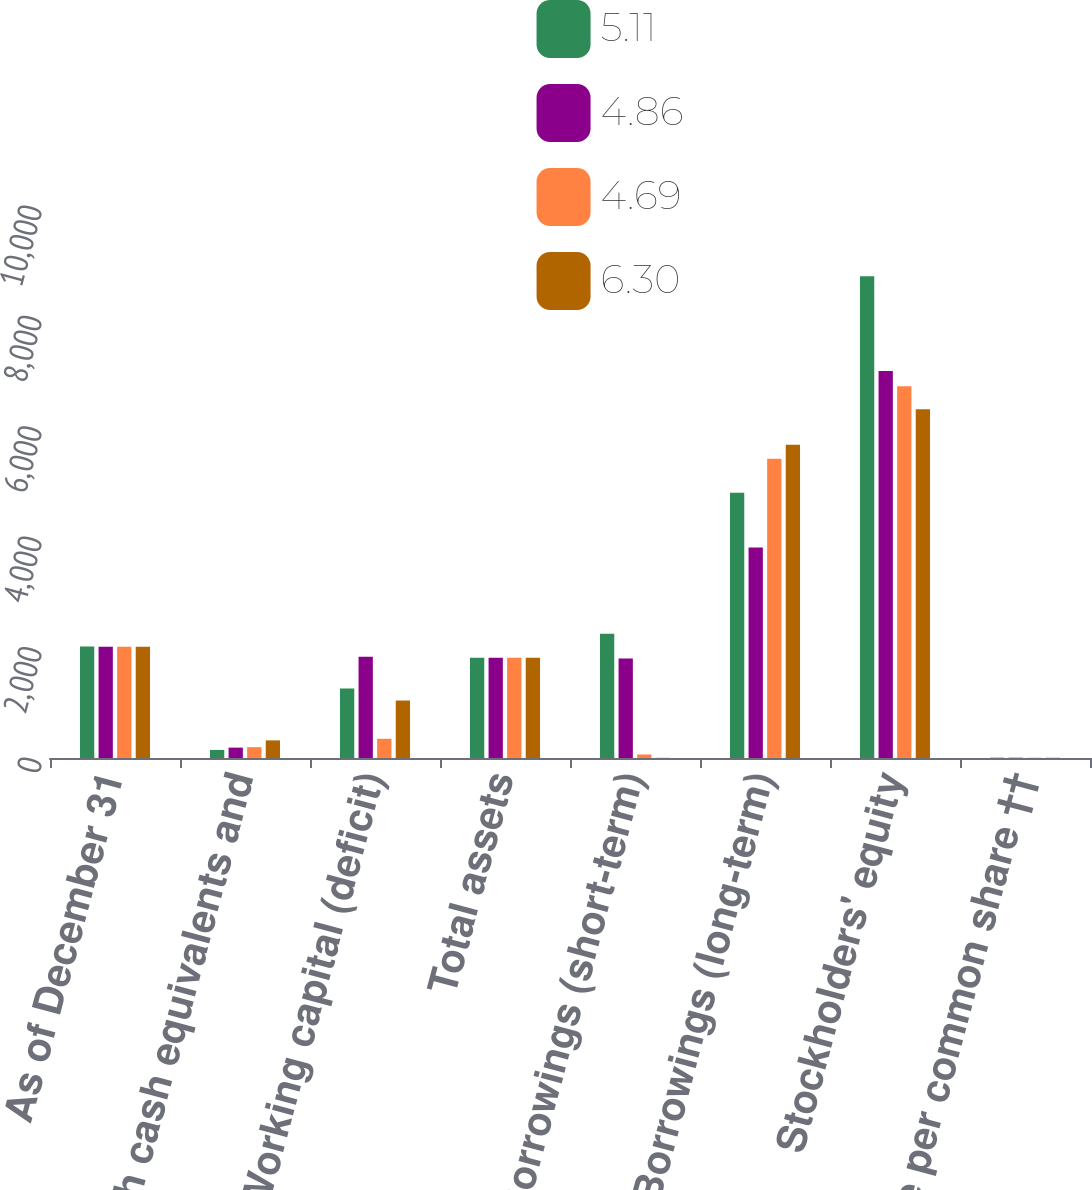<chart> <loc_0><loc_0><loc_500><loc_500><stacked_bar_chart><ecel><fcel>As of December 31<fcel>Cash cash equivalents and<fcel>Working capital (deficit)<fcel>Total assets<fcel>Borrowings (short-term)<fcel>Borrowings (long-term)<fcel>Stockholders' equity<fcel>Book value per common share ††<nl><fcel>5.11<fcel>2018<fcel>146<fcel>1257<fcel>1816.5<fcel>2253<fcel>4803<fcel>8726<fcel>6.3<nl><fcel>4.86<fcel>2017<fcel>188<fcel>1832<fcel>1816.5<fcel>1801<fcel>3815<fcel>7012<fcel>5.11<nl><fcel>4.69<fcel>2016<fcel>196<fcel>348<fcel>1816.5<fcel>64<fcel>5420<fcel>6733<fcel>4.94<nl><fcel>6.3<fcel>2015<fcel>319<fcel>1041<fcel>1816.5<fcel>3<fcel>5674<fcel>6320<fcel>4.69<nl></chart> 